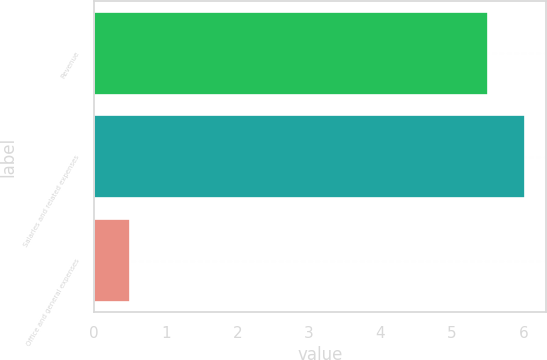<chart> <loc_0><loc_0><loc_500><loc_500><bar_chart><fcel>Revenue<fcel>Salaries and related expenses<fcel>Office and general expenses<nl><fcel>5.5<fcel>6.01<fcel>0.5<nl></chart> 